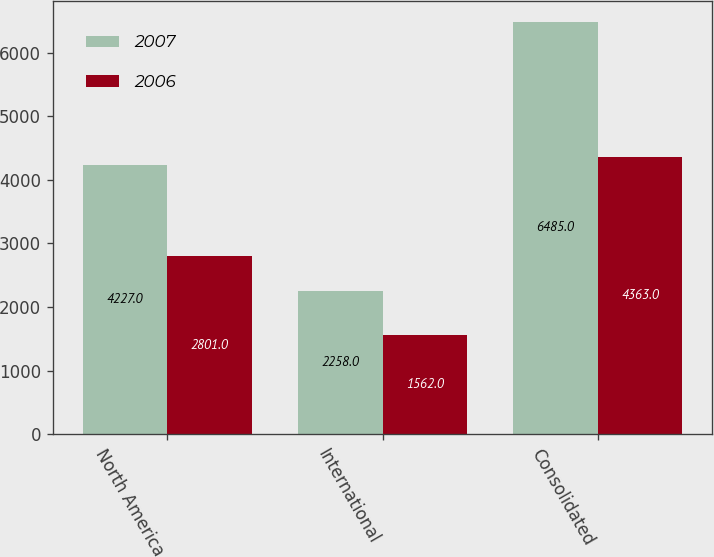Convert chart to OTSL. <chart><loc_0><loc_0><loc_500><loc_500><stacked_bar_chart><ecel><fcel>North America<fcel>International<fcel>Consolidated<nl><fcel>2007<fcel>4227<fcel>2258<fcel>6485<nl><fcel>2006<fcel>2801<fcel>1562<fcel>4363<nl></chart> 